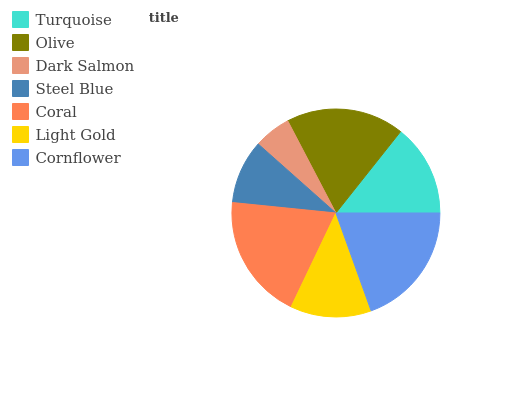Is Dark Salmon the minimum?
Answer yes or no. Yes. Is Coral the maximum?
Answer yes or no. Yes. Is Olive the minimum?
Answer yes or no. No. Is Olive the maximum?
Answer yes or no. No. Is Olive greater than Turquoise?
Answer yes or no. Yes. Is Turquoise less than Olive?
Answer yes or no. Yes. Is Turquoise greater than Olive?
Answer yes or no. No. Is Olive less than Turquoise?
Answer yes or no. No. Is Turquoise the high median?
Answer yes or no. Yes. Is Turquoise the low median?
Answer yes or no. Yes. Is Dark Salmon the high median?
Answer yes or no. No. Is Light Gold the low median?
Answer yes or no. No. 